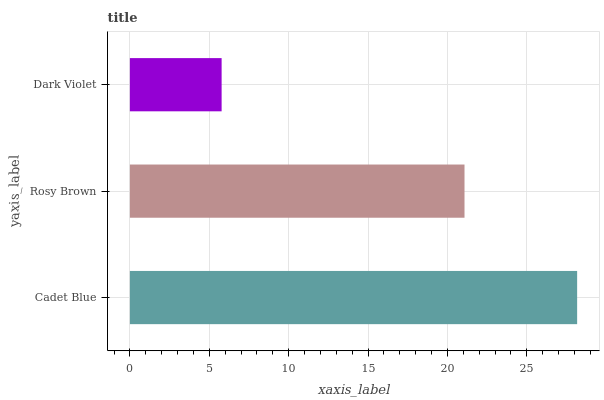Is Dark Violet the minimum?
Answer yes or no. Yes. Is Cadet Blue the maximum?
Answer yes or no. Yes. Is Rosy Brown the minimum?
Answer yes or no. No. Is Rosy Brown the maximum?
Answer yes or no. No. Is Cadet Blue greater than Rosy Brown?
Answer yes or no. Yes. Is Rosy Brown less than Cadet Blue?
Answer yes or no. Yes. Is Rosy Brown greater than Cadet Blue?
Answer yes or no. No. Is Cadet Blue less than Rosy Brown?
Answer yes or no. No. Is Rosy Brown the high median?
Answer yes or no. Yes. Is Rosy Brown the low median?
Answer yes or no. Yes. Is Cadet Blue the high median?
Answer yes or no. No. Is Cadet Blue the low median?
Answer yes or no. No. 